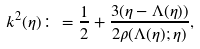Convert formula to latex. <formula><loc_0><loc_0><loc_500><loc_500>k ^ { 2 } ( \eta ) \colon = \frac { 1 } { 2 } + \frac { 3 ( \eta - \Lambda ( \eta ) ) } { 2 \rho ( \Lambda ( \eta ) ; \eta ) } ,</formula> 